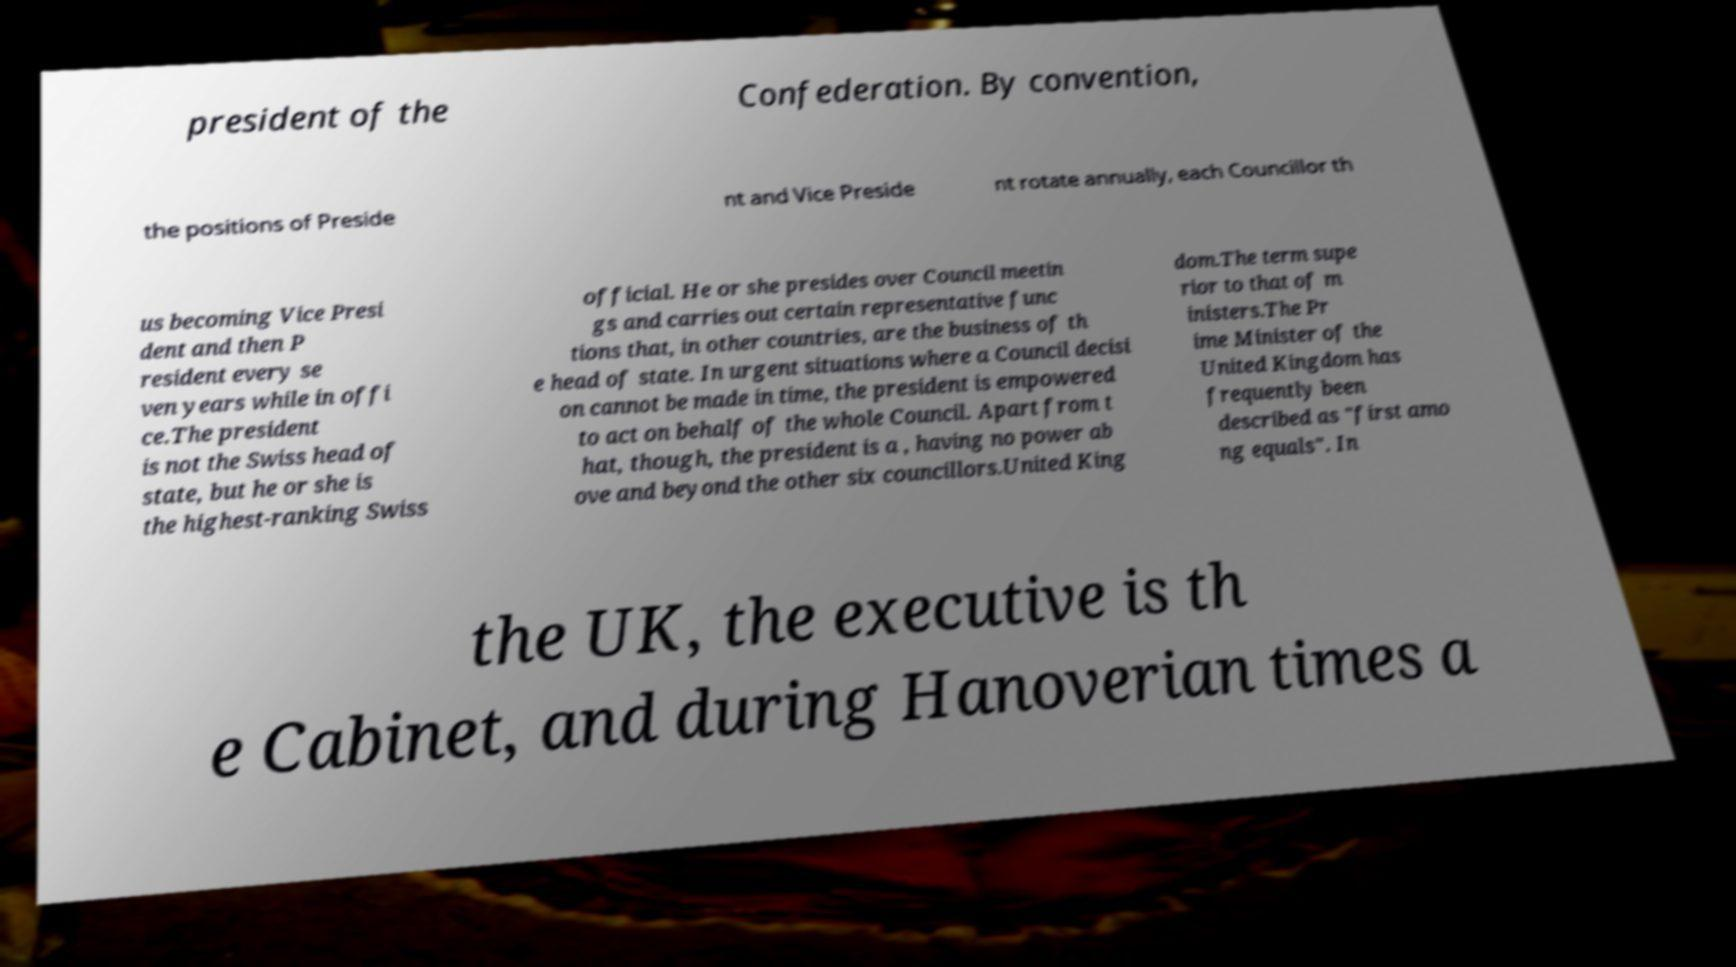For documentation purposes, I need the text within this image transcribed. Could you provide that? president of the Confederation. By convention, the positions of Preside nt and Vice Preside nt rotate annually, each Councillor th us becoming Vice Presi dent and then P resident every se ven years while in offi ce.The president is not the Swiss head of state, but he or she is the highest-ranking Swiss official. He or she presides over Council meetin gs and carries out certain representative func tions that, in other countries, are the business of th e head of state. In urgent situations where a Council decisi on cannot be made in time, the president is empowered to act on behalf of the whole Council. Apart from t hat, though, the president is a , having no power ab ove and beyond the other six councillors.United King dom.The term supe rior to that of m inisters.The Pr ime Minister of the United Kingdom has frequently been described as "first amo ng equals". In the UK, the executive is th e Cabinet, and during Hanoverian times a 